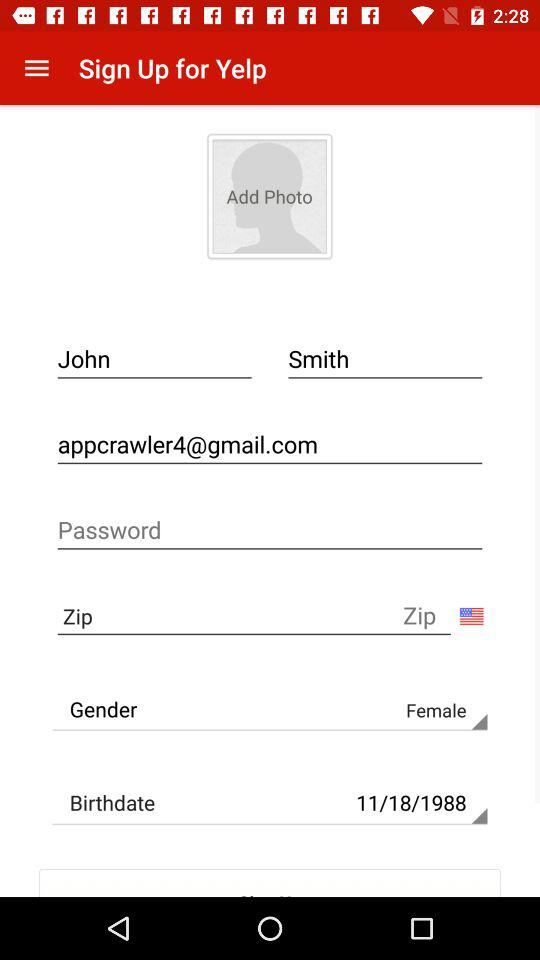What's the birth date? The birth date is 11/18/1988. 